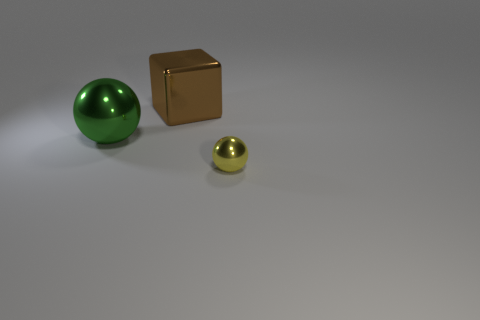How many tiny objects are there?
Your answer should be very brief. 1. What number of balls are brown rubber objects or big green shiny objects?
Offer a terse response. 1. What number of small yellow metallic things are on the left side of the object that is behind the green metal ball?
Provide a succinct answer. 0. Is there another cube that has the same material as the block?
Give a very brief answer. No. What color is the shiny sphere behind the metal sphere in front of the shiny ball that is behind the small object?
Offer a terse response. Green. How many green objects are either small metallic spheres or big metallic objects?
Offer a very short reply. 1. What number of big green objects are the same shape as the tiny yellow thing?
Your response must be concise. 1. There is a green thing that is the same size as the brown metallic cube; what is its shape?
Your answer should be very brief. Sphere. There is a big brown metal object; are there any large shiny spheres on the right side of it?
Your response must be concise. No. Is there a large green shiny thing that is behind the sphere on the left side of the large brown metal cube?
Provide a succinct answer. No. 